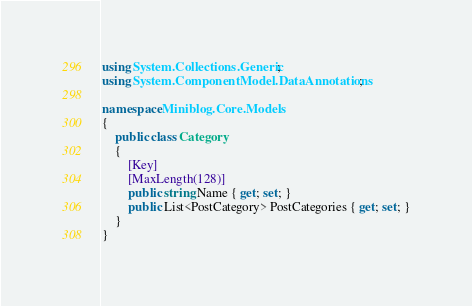<code> <loc_0><loc_0><loc_500><loc_500><_C#_>using System.Collections.Generic;
using System.ComponentModel.DataAnnotations;

namespace Miniblog.Core.Models
{
    public class Category
    {
        [Key]
        [MaxLength(128)]
        public string Name { get; set; }
        public List<PostCategory> PostCategories { get; set; }
    }
}</code> 